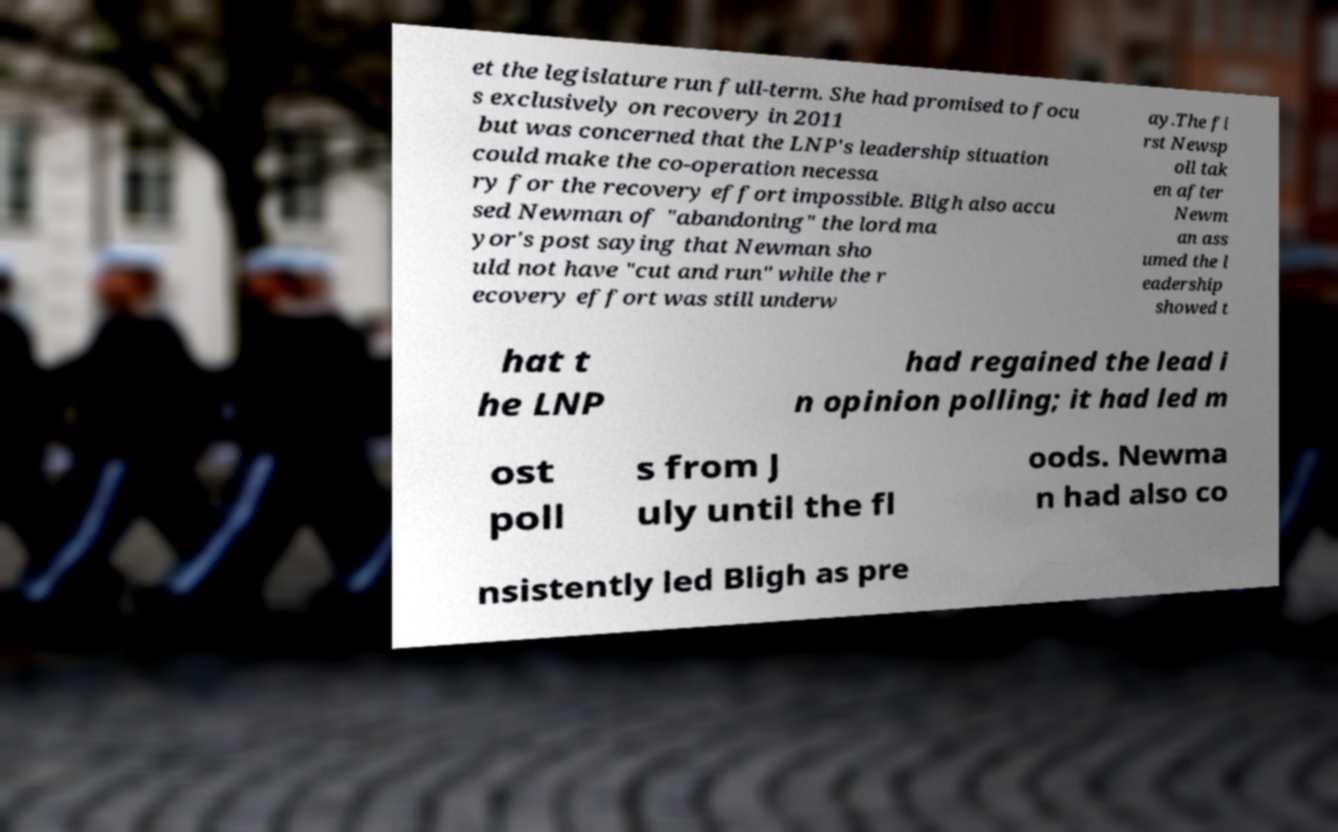Can you accurately transcribe the text from the provided image for me? et the legislature run full-term. She had promised to focu s exclusively on recovery in 2011 but was concerned that the LNP's leadership situation could make the co-operation necessa ry for the recovery effort impossible. Bligh also accu sed Newman of "abandoning" the lord ma yor's post saying that Newman sho uld not have "cut and run" while the r ecovery effort was still underw ay.The fi rst Newsp oll tak en after Newm an ass umed the l eadership showed t hat t he LNP had regained the lead i n opinion polling; it had led m ost poll s from J uly until the fl oods. Newma n had also co nsistently led Bligh as pre 